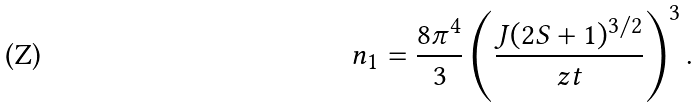<formula> <loc_0><loc_0><loc_500><loc_500>n _ { 1 } = \frac { 8 \pi ^ { 4 } } { 3 } \left ( \frac { J ( 2 S + 1 ) ^ { 3 / 2 } } { z t } \right ) ^ { 3 } .</formula> 